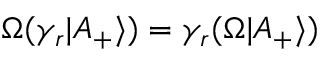Convert formula to latex. <formula><loc_0><loc_0><loc_500><loc_500>\Omega ( \gamma _ { r } | A _ { + } \rangle ) = \gamma _ { r } ( \Omega | A _ { + } \rangle )</formula> 